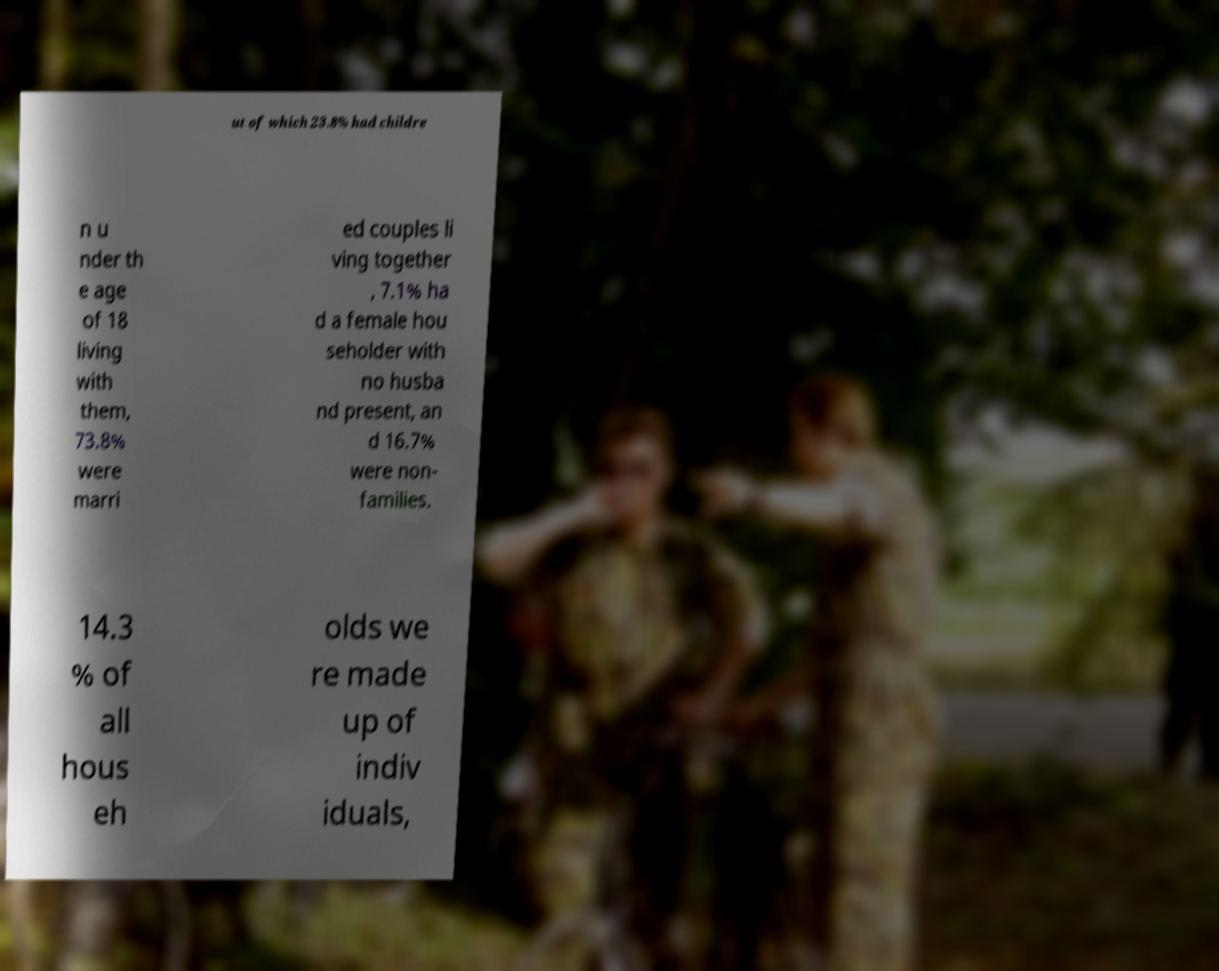I need the written content from this picture converted into text. Can you do that? ut of which 23.8% had childre n u nder th e age of 18 living with them, 73.8% were marri ed couples li ving together , 7.1% ha d a female hou seholder with no husba nd present, an d 16.7% were non- families. 14.3 % of all hous eh olds we re made up of indiv iduals, 